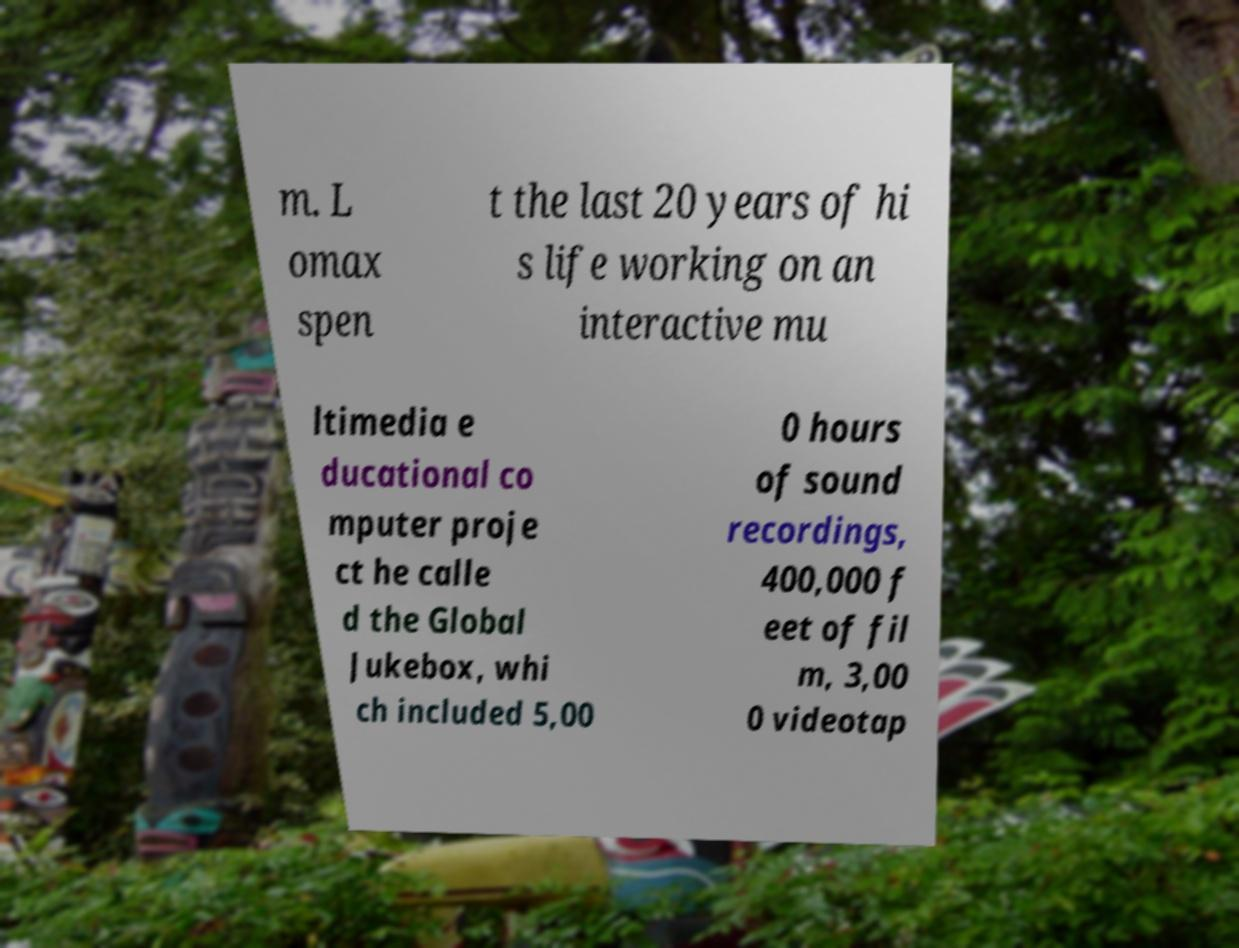Please identify and transcribe the text found in this image. m. L omax spen t the last 20 years of hi s life working on an interactive mu ltimedia e ducational co mputer proje ct he calle d the Global Jukebox, whi ch included 5,00 0 hours of sound recordings, 400,000 f eet of fil m, 3,00 0 videotap 